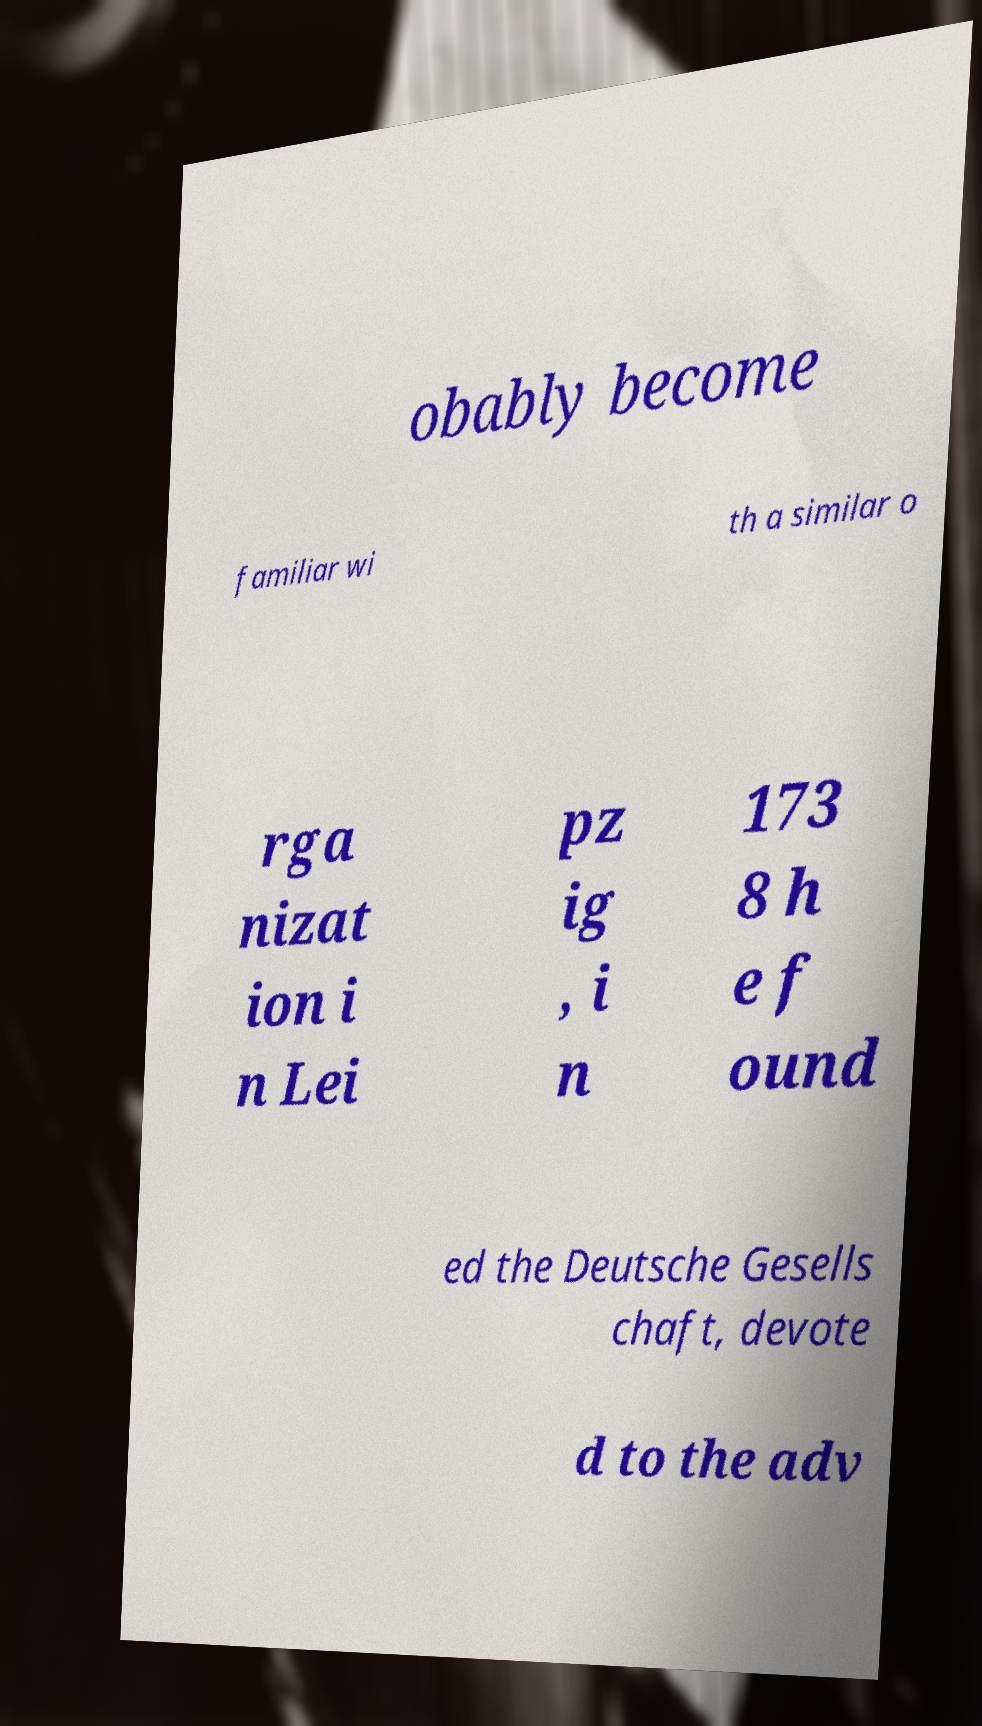Can you read and provide the text displayed in the image?This photo seems to have some interesting text. Can you extract and type it out for me? obably become familiar wi th a similar o rga nizat ion i n Lei pz ig , i n 173 8 h e f ound ed the Deutsche Gesells chaft, devote d to the adv 